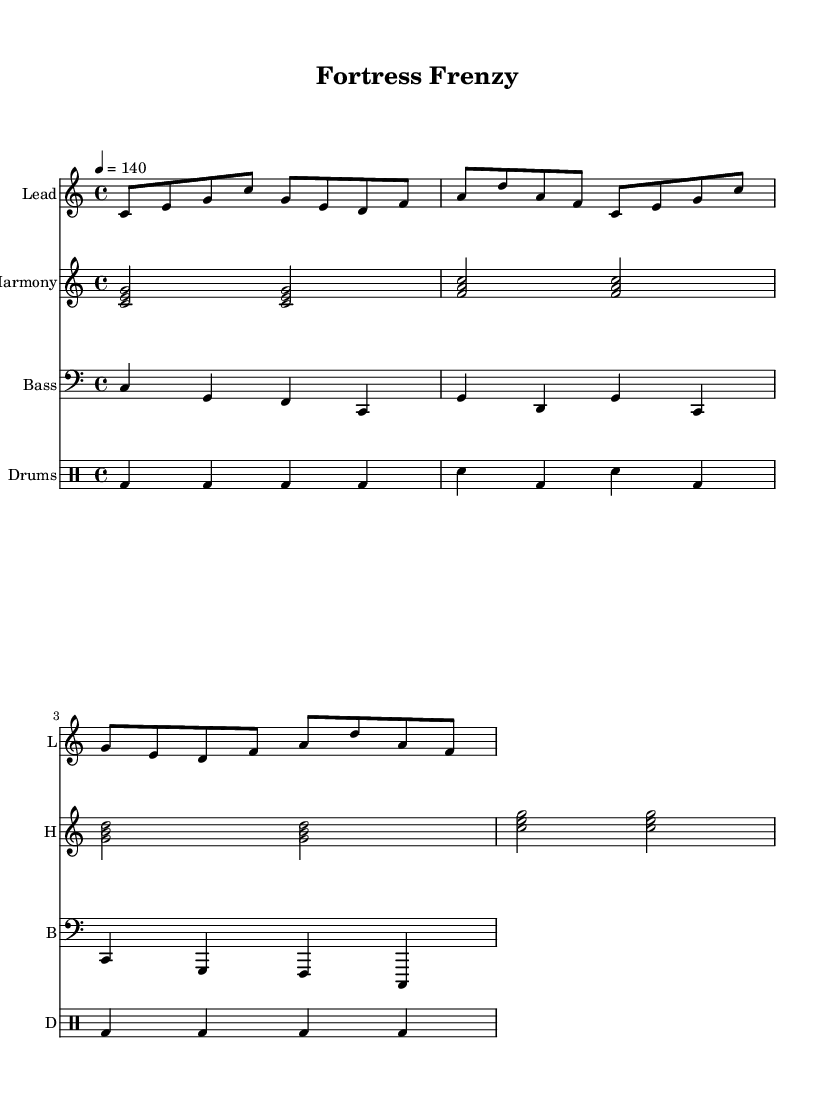What is the key signature of this music? The key signature is indicated at the beginning of the sheet music where it shows "c" for C major, implying there are no sharps or flats.
Answer: C major What is the time signature of this music? The time signature is shown at the beginning, and it specifies "4/4," which indicates that there are four beats per measure and a quarter note gets one beat.
Answer: 4/4 What is the tempo marking for this piece? The tempo marking is indicated as "4 = 140," which means there are 140 beats per minute, guiding the performance speed of the music.
Answer: 140 How many measures are in the melody part? By counting the number of bar lines in the melody section, we find there are four distinct measures represented.
Answer: 4 Which instrument plays the drums? The drum staff is labeled with "Drums" at the top, making it clear that this part is intended for drum performance.
Answer: Drums What is the starting note of the melody? The melody begins on the note "C" as indicated by the first note in the staff, which is located on the first line of the treble clef.
Answer: C What type of harmony is used in this piece? The harmony consists of triads, as seen in the notes grouped together in the harmony staff, which are formed in chords of three notes.
Answer: Triads 